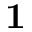Convert formula to latex. <formula><loc_0><loc_0><loc_500><loc_500>{ 1 }</formula> 